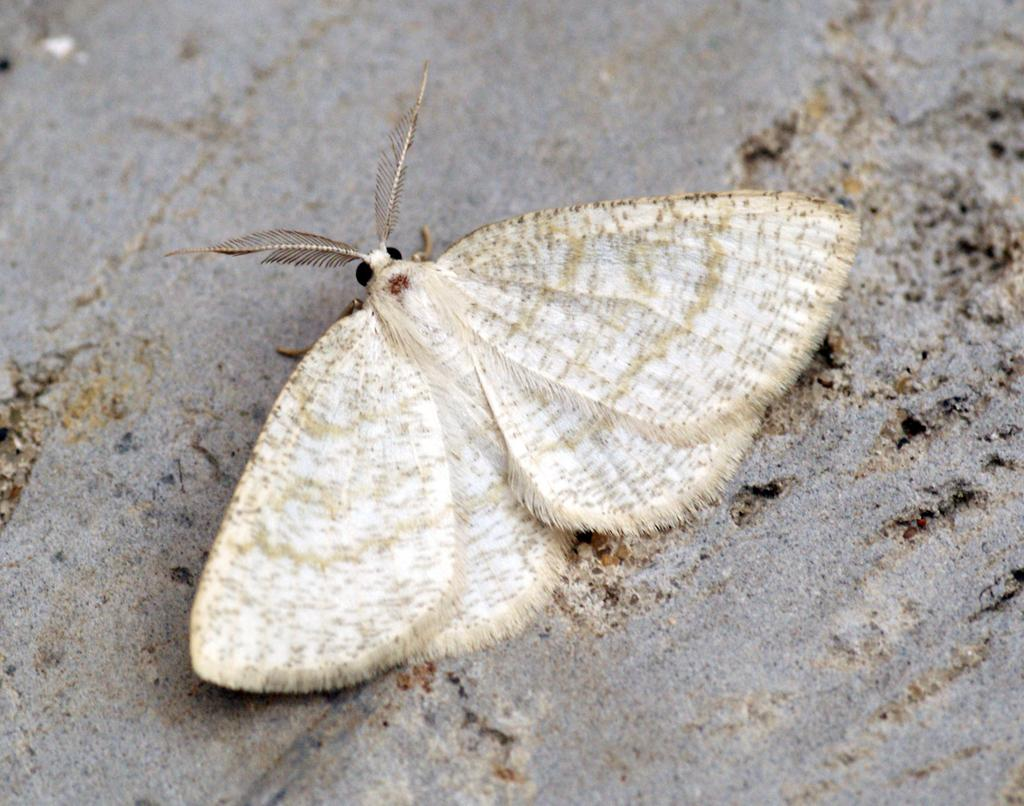What type of animal can be seen in the image? There is a butterfly in the image. What color is the butterfly? The butterfly is white in color. What can be seen in the background of the image? There is sand visible in the background of the image. What flavor of ice cream is the boy eating in the image? There is no boy or ice cream present in the image; it features a white butterfly and sand in the background. 